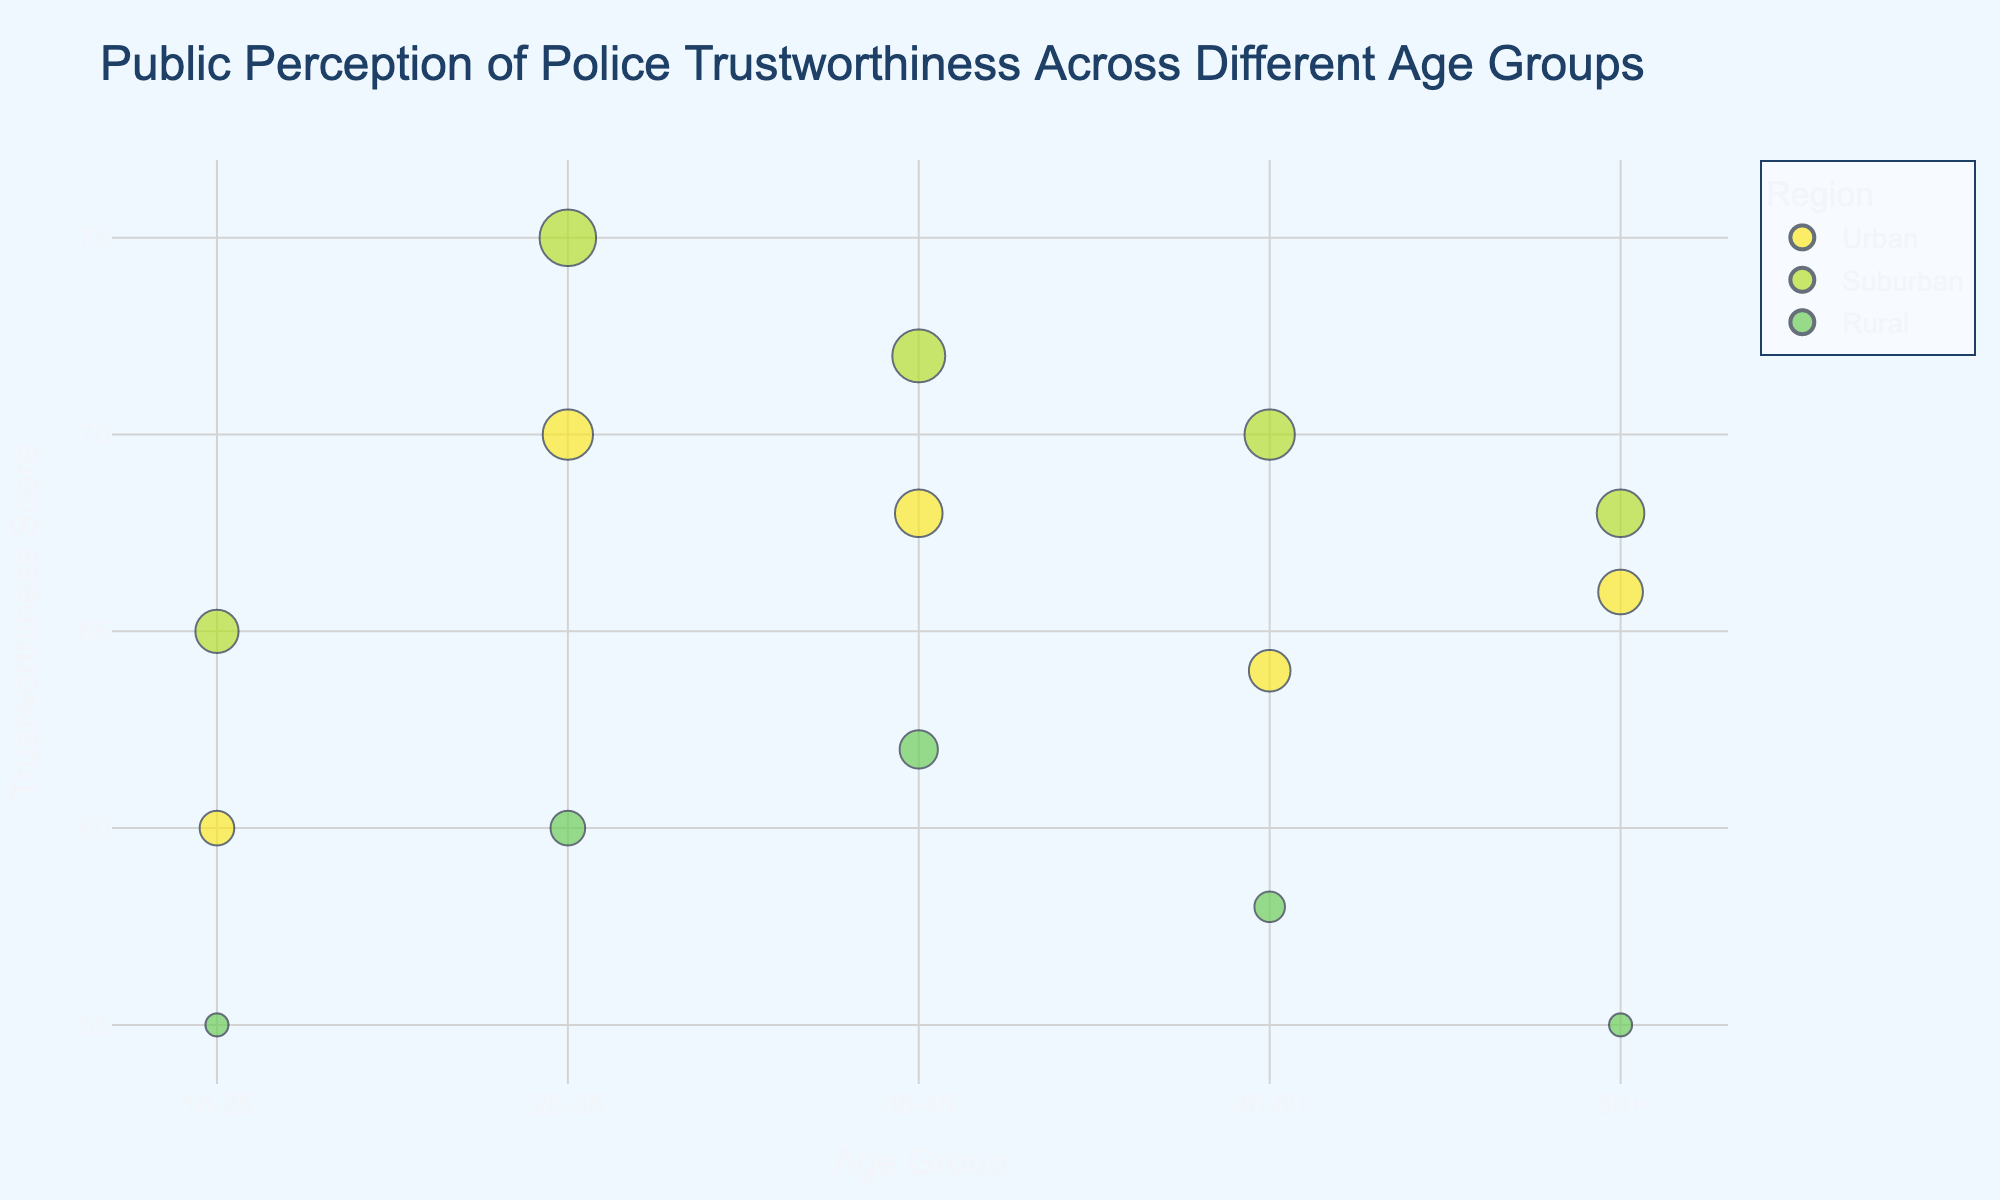What is the title of the figure? The title of the figure is prominently displayed at the top. It reads "Public Perception of Police Trustworthiness Across Different Age Groups".
Answer: Public Perception of Police Trustworthiness Across Different Age Groups How many regions are represented in the figure? By looking at the legend and the different colors in the bubble chart, we can count the distinct regions represented. There are three regions: Urban, Suburban, and Rural.
Answer: Three Which age group shows the highest trustworthiness score? We need to look at the y-axis for the trustworthiness scores and identify the bubble with the highest position. The age group 26-35 Suburban has the highest trustworthiness score of 75.
Answer: 26-35 Suburban What community engagement initiative is associated with the 18-25 Urban age group? Hover over the bubble representing the 18-25 Urban age group to read the information about the community engagement initiative. It is "Youth Outreach Programs".
Answer: Youth Outreach Programs Which age group and region has the lowest trustworthiness score? By observing the position of the bubbles on the y-axis, the lowest position corresponds to the lowest trustworthiness score. The 18-25 Rural age group has the lowest score of 55.
Answer: 18-25 Rural What is the difference in trustworthiness score between 46-60 Urban and 46-60 Rural age groups? First, identify the scores for both age groups. 46-60 Urban has a trustworthiness score of 64, and 46-60 Rural has a score of 58. Calculating the difference, 64 - 58 equals 6.
Answer: 6 Which region shows the highest trustworthiness in the 36-45 age group? Observing the bubbles corresponding to the 36-45 age group and comparing their y-axis values, we identify that Suburban has the highest score of 72.
Answer: Suburban How does the trustworthiness score of 60+ Urban compare to that of 18-25 Urban? By considering the y-axis values for these two points, 60+ Urban has a score of 66, while 18-25 Urban has a score of 60. Hence, 60+ Urban has a higher trustworthiness score than 18-25 Urban.
Answer: Higher What community engagement initiative is associated with the highest trustworthiness score? Hover over the bubble with the highest trustworthiness score of 75, which belongs to the 26-35 Suburban group. The community engagement initiative is "Technology-based Engagement".
Answer: Technology-based Engagement What is the average trustworthiness score for the Rural region across all age groups? Collect the trustworthiness scores for Rural in each age group: 18-25 (55), 26-35 (60), 36-45 (62), 46-60 (58), and 60+ (55). Calculate the average: (55 + 60 + 62 + 58 + 55) / 5 = 58.
Answer: 58 